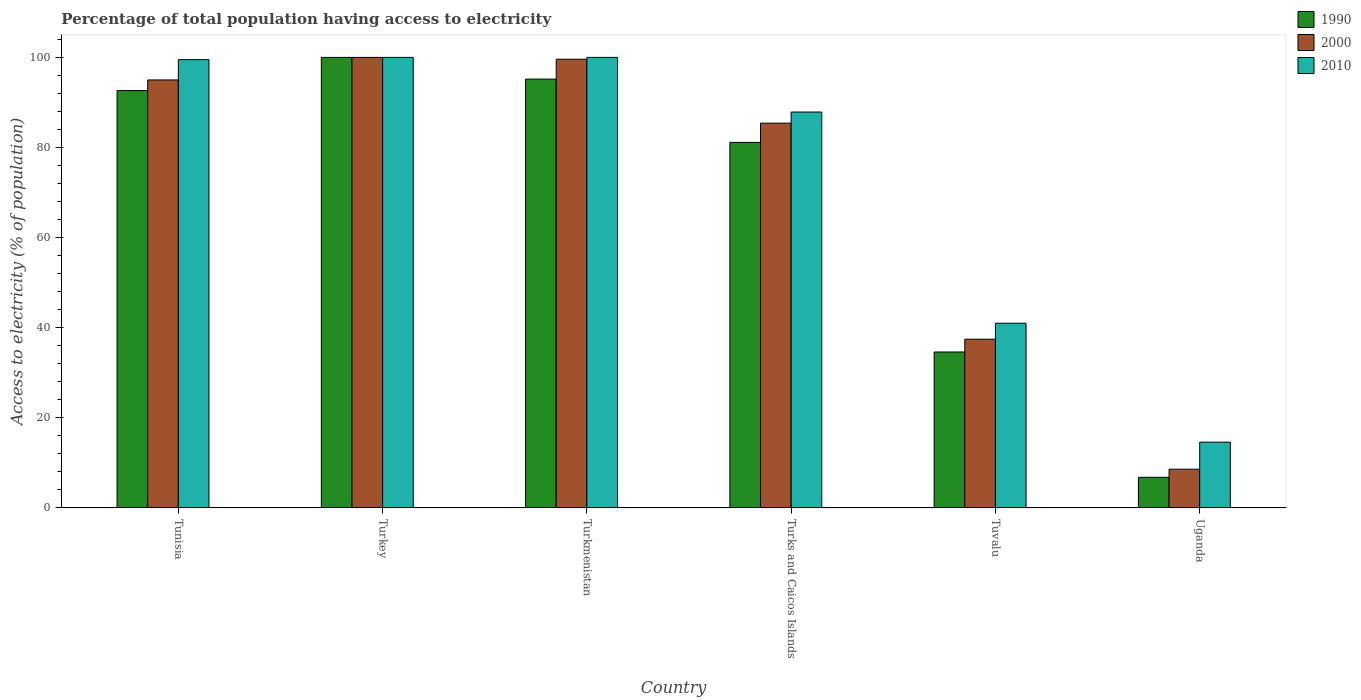How many different coloured bars are there?
Make the answer very short. 3. Are the number of bars per tick equal to the number of legend labels?
Provide a short and direct response. Yes. How many bars are there on the 2nd tick from the left?
Provide a succinct answer. 3. What is the label of the 4th group of bars from the left?
Offer a terse response. Turks and Caicos Islands. What is the percentage of population that have access to electricity in 2000 in Tunisia?
Keep it short and to the point. 95. In which country was the percentage of population that have access to electricity in 2000 minimum?
Give a very brief answer. Uganda. What is the total percentage of population that have access to electricity in 1990 in the graph?
Keep it short and to the point. 410.38. What is the difference between the percentage of population that have access to electricity in 2010 in Tunisia and that in Turkey?
Your answer should be very brief. -0.5. What is the average percentage of population that have access to electricity in 2010 per country?
Provide a succinct answer. 73.83. In how many countries, is the percentage of population that have access to electricity in 1990 greater than 48 %?
Ensure brevity in your answer.  4. What is the ratio of the percentage of population that have access to electricity in 2000 in Turkmenistan to that in Turks and Caicos Islands?
Give a very brief answer. 1.17. Is the percentage of population that have access to electricity in 2010 in Turkmenistan less than that in Uganda?
Keep it short and to the point. No. What is the difference between the highest and the second highest percentage of population that have access to electricity in 2010?
Your answer should be very brief. -0.5. What is the difference between the highest and the lowest percentage of population that have access to electricity in 2010?
Ensure brevity in your answer.  85.4. In how many countries, is the percentage of population that have access to electricity in 2010 greater than the average percentage of population that have access to electricity in 2010 taken over all countries?
Your answer should be compact. 4. Is the sum of the percentage of population that have access to electricity in 2000 in Turkey and Tuvalu greater than the maximum percentage of population that have access to electricity in 1990 across all countries?
Your answer should be compact. Yes. What does the 1st bar from the right in Turkey represents?
Offer a very short reply. 2010. Is it the case that in every country, the sum of the percentage of population that have access to electricity in 2010 and percentage of population that have access to electricity in 1990 is greater than the percentage of population that have access to electricity in 2000?
Your answer should be very brief. Yes. Are all the bars in the graph horizontal?
Your answer should be very brief. No. How many countries are there in the graph?
Your answer should be compact. 6. Does the graph contain any zero values?
Provide a succinct answer. No. Does the graph contain grids?
Offer a terse response. No. How are the legend labels stacked?
Your response must be concise. Vertical. What is the title of the graph?
Keep it short and to the point. Percentage of total population having access to electricity. Does "1999" appear as one of the legend labels in the graph?
Give a very brief answer. No. What is the label or title of the Y-axis?
Provide a short and direct response. Access to electricity (% of population). What is the Access to electricity (% of population) in 1990 in Tunisia?
Ensure brevity in your answer.  92.64. What is the Access to electricity (% of population) in 2000 in Tunisia?
Your answer should be compact. 95. What is the Access to electricity (% of population) of 2010 in Tunisia?
Give a very brief answer. 99.5. What is the Access to electricity (% of population) in 1990 in Turkey?
Your answer should be compact. 100. What is the Access to electricity (% of population) of 2010 in Turkey?
Your answer should be compact. 100. What is the Access to electricity (% of population) of 1990 in Turkmenistan?
Ensure brevity in your answer.  95.19. What is the Access to electricity (% of population) in 2000 in Turkmenistan?
Offer a very short reply. 99.6. What is the Access to electricity (% of population) of 1990 in Turks and Caicos Islands?
Offer a terse response. 81.14. What is the Access to electricity (% of population) in 2000 in Turks and Caicos Islands?
Provide a short and direct response. 85.41. What is the Access to electricity (% of population) in 2010 in Turks and Caicos Islands?
Make the answer very short. 87.87. What is the Access to electricity (% of population) of 1990 in Tuvalu?
Provide a short and direct response. 34.62. What is the Access to electricity (% of population) in 2000 in Tuvalu?
Offer a terse response. 37.46. What is the Access to electricity (% of population) in 2010 in Tuvalu?
Provide a succinct answer. 41. What is the Access to electricity (% of population) in 2010 in Uganda?
Ensure brevity in your answer.  14.6. Across all countries, what is the maximum Access to electricity (% of population) in 1990?
Offer a very short reply. 100. Across all countries, what is the maximum Access to electricity (% of population) in 2000?
Your answer should be very brief. 100. Across all countries, what is the minimum Access to electricity (% of population) in 1990?
Provide a succinct answer. 6.8. Across all countries, what is the minimum Access to electricity (% of population) of 2000?
Provide a succinct answer. 8.6. Across all countries, what is the minimum Access to electricity (% of population) of 2010?
Provide a short and direct response. 14.6. What is the total Access to electricity (% of population) of 1990 in the graph?
Provide a short and direct response. 410.38. What is the total Access to electricity (% of population) in 2000 in the graph?
Your answer should be very brief. 426.07. What is the total Access to electricity (% of population) in 2010 in the graph?
Ensure brevity in your answer.  442.97. What is the difference between the Access to electricity (% of population) in 1990 in Tunisia and that in Turkey?
Provide a succinct answer. -7.36. What is the difference between the Access to electricity (% of population) in 1990 in Tunisia and that in Turkmenistan?
Your response must be concise. -2.55. What is the difference between the Access to electricity (% of population) in 1990 in Tunisia and that in Turks and Caicos Islands?
Offer a terse response. 11.5. What is the difference between the Access to electricity (% of population) of 2000 in Tunisia and that in Turks and Caicos Islands?
Your answer should be very brief. 9.59. What is the difference between the Access to electricity (% of population) in 2010 in Tunisia and that in Turks and Caicos Islands?
Your response must be concise. 11.63. What is the difference between the Access to electricity (% of population) of 1990 in Tunisia and that in Tuvalu?
Provide a short and direct response. 58.02. What is the difference between the Access to electricity (% of population) of 2000 in Tunisia and that in Tuvalu?
Keep it short and to the point. 57.54. What is the difference between the Access to electricity (% of population) in 2010 in Tunisia and that in Tuvalu?
Provide a succinct answer. 58.5. What is the difference between the Access to electricity (% of population) of 1990 in Tunisia and that in Uganda?
Your answer should be compact. 85.84. What is the difference between the Access to electricity (% of population) of 2000 in Tunisia and that in Uganda?
Provide a succinct answer. 86.4. What is the difference between the Access to electricity (% of population) of 2010 in Tunisia and that in Uganda?
Give a very brief answer. 84.9. What is the difference between the Access to electricity (% of population) in 1990 in Turkey and that in Turkmenistan?
Your answer should be compact. 4.81. What is the difference between the Access to electricity (% of population) in 2010 in Turkey and that in Turkmenistan?
Offer a very short reply. 0. What is the difference between the Access to electricity (% of population) of 1990 in Turkey and that in Turks and Caicos Islands?
Provide a succinct answer. 18.86. What is the difference between the Access to electricity (% of population) in 2000 in Turkey and that in Turks and Caicos Islands?
Give a very brief answer. 14.59. What is the difference between the Access to electricity (% of population) of 2010 in Turkey and that in Turks and Caicos Islands?
Ensure brevity in your answer.  12.13. What is the difference between the Access to electricity (% of population) in 1990 in Turkey and that in Tuvalu?
Your response must be concise. 65.38. What is the difference between the Access to electricity (% of population) in 2000 in Turkey and that in Tuvalu?
Provide a short and direct response. 62.54. What is the difference between the Access to electricity (% of population) of 2010 in Turkey and that in Tuvalu?
Ensure brevity in your answer.  59. What is the difference between the Access to electricity (% of population) of 1990 in Turkey and that in Uganda?
Ensure brevity in your answer.  93.2. What is the difference between the Access to electricity (% of population) in 2000 in Turkey and that in Uganda?
Make the answer very short. 91.4. What is the difference between the Access to electricity (% of population) in 2010 in Turkey and that in Uganda?
Provide a short and direct response. 85.4. What is the difference between the Access to electricity (% of population) of 1990 in Turkmenistan and that in Turks and Caicos Islands?
Your response must be concise. 14.05. What is the difference between the Access to electricity (% of population) of 2000 in Turkmenistan and that in Turks and Caicos Islands?
Your answer should be very brief. 14.19. What is the difference between the Access to electricity (% of population) in 2010 in Turkmenistan and that in Turks and Caicos Islands?
Provide a short and direct response. 12.13. What is the difference between the Access to electricity (% of population) of 1990 in Turkmenistan and that in Tuvalu?
Give a very brief answer. 60.57. What is the difference between the Access to electricity (% of population) of 2000 in Turkmenistan and that in Tuvalu?
Keep it short and to the point. 62.14. What is the difference between the Access to electricity (% of population) in 1990 in Turkmenistan and that in Uganda?
Provide a succinct answer. 88.39. What is the difference between the Access to electricity (% of population) of 2000 in Turkmenistan and that in Uganda?
Your response must be concise. 91. What is the difference between the Access to electricity (% of population) in 2010 in Turkmenistan and that in Uganda?
Your answer should be very brief. 85.4. What is the difference between the Access to electricity (% of population) in 1990 in Turks and Caicos Islands and that in Tuvalu?
Provide a succinct answer. 46.52. What is the difference between the Access to electricity (% of population) of 2000 in Turks and Caicos Islands and that in Tuvalu?
Make the answer very short. 47.96. What is the difference between the Access to electricity (% of population) in 2010 in Turks and Caicos Islands and that in Tuvalu?
Offer a very short reply. 46.87. What is the difference between the Access to electricity (% of population) of 1990 in Turks and Caicos Islands and that in Uganda?
Provide a short and direct response. 74.34. What is the difference between the Access to electricity (% of population) in 2000 in Turks and Caicos Islands and that in Uganda?
Keep it short and to the point. 76.81. What is the difference between the Access to electricity (% of population) of 2010 in Turks and Caicos Islands and that in Uganda?
Provide a short and direct response. 73.27. What is the difference between the Access to electricity (% of population) in 1990 in Tuvalu and that in Uganda?
Provide a succinct answer. 27.82. What is the difference between the Access to electricity (% of population) in 2000 in Tuvalu and that in Uganda?
Ensure brevity in your answer.  28.86. What is the difference between the Access to electricity (% of population) of 2010 in Tuvalu and that in Uganda?
Offer a terse response. 26.4. What is the difference between the Access to electricity (% of population) of 1990 in Tunisia and the Access to electricity (% of population) of 2000 in Turkey?
Offer a terse response. -7.36. What is the difference between the Access to electricity (% of population) of 1990 in Tunisia and the Access to electricity (% of population) of 2010 in Turkey?
Offer a very short reply. -7.36. What is the difference between the Access to electricity (% of population) in 2000 in Tunisia and the Access to electricity (% of population) in 2010 in Turkey?
Your response must be concise. -5. What is the difference between the Access to electricity (% of population) of 1990 in Tunisia and the Access to electricity (% of population) of 2000 in Turkmenistan?
Your response must be concise. -6.96. What is the difference between the Access to electricity (% of population) in 1990 in Tunisia and the Access to electricity (% of population) in 2010 in Turkmenistan?
Provide a short and direct response. -7.36. What is the difference between the Access to electricity (% of population) in 2000 in Tunisia and the Access to electricity (% of population) in 2010 in Turkmenistan?
Your response must be concise. -5. What is the difference between the Access to electricity (% of population) of 1990 in Tunisia and the Access to electricity (% of population) of 2000 in Turks and Caicos Islands?
Your answer should be compact. 7.23. What is the difference between the Access to electricity (% of population) of 1990 in Tunisia and the Access to electricity (% of population) of 2010 in Turks and Caicos Islands?
Your answer should be very brief. 4.76. What is the difference between the Access to electricity (% of population) of 2000 in Tunisia and the Access to electricity (% of population) of 2010 in Turks and Caicos Islands?
Offer a terse response. 7.13. What is the difference between the Access to electricity (% of population) in 1990 in Tunisia and the Access to electricity (% of population) in 2000 in Tuvalu?
Your answer should be very brief. 55.18. What is the difference between the Access to electricity (% of population) in 1990 in Tunisia and the Access to electricity (% of population) in 2010 in Tuvalu?
Offer a terse response. 51.64. What is the difference between the Access to electricity (% of population) of 2000 in Tunisia and the Access to electricity (% of population) of 2010 in Tuvalu?
Make the answer very short. 54. What is the difference between the Access to electricity (% of population) of 1990 in Tunisia and the Access to electricity (% of population) of 2000 in Uganda?
Offer a very short reply. 84.04. What is the difference between the Access to electricity (% of population) of 1990 in Tunisia and the Access to electricity (% of population) of 2010 in Uganda?
Give a very brief answer. 78.04. What is the difference between the Access to electricity (% of population) in 2000 in Tunisia and the Access to electricity (% of population) in 2010 in Uganda?
Provide a succinct answer. 80.4. What is the difference between the Access to electricity (% of population) of 1990 in Turkey and the Access to electricity (% of population) of 2010 in Turkmenistan?
Provide a succinct answer. 0. What is the difference between the Access to electricity (% of population) in 1990 in Turkey and the Access to electricity (% of population) in 2000 in Turks and Caicos Islands?
Make the answer very short. 14.59. What is the difference between the Access to electricity (% of population) in 1990 in Turkey and the Access to electricity (% of population) in 2010 in Turks and Caicos Islands?
Your response must be concise. 12.13. What is the difference between the Access to electricity (% of population) of 2000 in Turkey and the Access to electricity (% of population) of 2010 in Turks and Caicos Islands?
Give a very brief answer. 12.13. What is the difference between the Access to electricity (% of population) of 1990 in Turkey and the Access to electricity (% of population) of 2000 in Tuvalu?
Offer a very short reply. 62.54. What is the difference between the Access to electricity (% of population) in 2000 in Turkey and the Access to electricity (% of population) in 2010 in Tuvalu?
Give a very brief answer. 59. What is the difference between the Access to electricity (% of population) in 1990 in Turkey and the Access to electricity (% of population) in 2000 in Uganda?
Make the answer very short. 91.4. What is the difference between the Access to electricity (% of population) of 1990 in Turkey and the Access to electricity (% of population) of 2010 in Uganda?
Provide a succinct answer. 85.4. What is the difference between the Access to electricity (% of population) of 2000 in Turkey and the Access to electricity (% of population) of 2010 in Uganda?
Make the answer very short. 85.4. What is the difference between the Access to electricity (% of population) of 1990 in Turkmenistan and the Access to electricity (% of population) of 2000 in Turks and Caicos Islands?
Offer a terse response. 9.78. What is the difference between the Access to electricity (% of population) of 1990 in Turkmenistan and the Access to electricity (% of population) of 2010 in Turks and Caicos Islands?
Make the answer very short. 7.31. What is the difference between the Access to electricity (% of population) of 2000 in Turkmenistan and the Access to electricity (% of population) of 2010 in Turks and Caicos Islands?
Give a very brief answer. 11.73. What is the difference between the Access to electricity (% of population) in 1990 in Turkmenistan and the Access to electricity (% of population) in 2000 in Tuvalu?
Keep it short and to the point. 57.73. What is the difference between the Access to electricity (% of population) in 1990 in Turkmenistan and the Access to electricity (% of population) in 2010 in Tuvalu?
Your response must be concise. 54.19. What is the difference between the Access to electricity (% of population) in 2000 in Turkmenistan and the Access to electricity (% of population) in 2010 in Tuvalu?
Your response must be concise. 58.6. What is the difference between the Access to electricity (% of population) in 1990 in Turkmenistan and the Access to electricity (% of population) in 2000 in Uganda?
Make the answer very short. 86.59. What is the difference between the Access to electricity (% of population) of 1990 in Turkmenistan and the Access to electricity (% of population) of 2010 in Uganda?
Your response must be concise. 80.59. What is the difference between the Access to electricity (% of population) in 1990 in Turks and Caicos Islands and the Access to electricity (% of population) in 2000 in Tuvalu?
Make the answer very short. 43.68. What is the difference between the Access to electricity (% of population) in 1990 in Turks and Caicos Islands and the Access to electricity (% of population) in 2010 in Tuvalu?
Your response must be concise. 40.14. What is the difference between the Access to electricity (% of population) in 2000 in Turks and Caicos Islands and the Access to electricity (% of population) in 2010 in Tuvalu?
Your answer should be compact. 44.41. What is the difference between the Access to electricity (% of population) of 1990 in Turks and Caicos Islands and the Access to electricity (% of population) of 2000 in Uganda?
Your answer should be compact. 72.54. What is the difference between the Access to electricity (% of population) in 1990 in Turks and Caicos Islands and the Access to electricity (% of population) in 2010 in Uganda?
Your response must be concise. 66.54. What is the difference between the Access to electricity (% of population) of 2000 in Turks and Caicos Islands and the Access to electricity (% of population) of 2010 in Uganda?
Your response must be concise. 70.81. What is the difference between the Access to electricity (% of population) of 1990 in Tuvalu and the Access to electricity (% of population) of 2000 in Uganda?
Your answer should be compact. 26.02. What is the difference between the Access to electricity (% of population) in 1990 in Tuvalu and the Access to electricity (% of population) in 2010 in Uganda?
Provide a succinct answer. 20.02. What is the difference between the Access to electricity (% of population) in 2000 in Tuvalu and the Access to electricity (% of population) in 2010 in Uganda?
Provide a succinct answer. 22.86. What is the average Access to electricity (% of population) of 1990 per country?
Offer a very short reply. 68.4. What is the average Access to electricity (% of population) in 2000 per country?
Your answer should be compact. 71.01. What is the average Access to electricity (% of population) in 2010 per country?
Your answer should be compact. 73.83. What is the difference between the Access to electricity (% of population) of 1990 and Access to electricity (% of population) of 2000 in Tunisia?
Your response must be concise. -2.36. What is the difference between the Access to electricity (% of population) in 1990 and Access to electricity (% of population) in 2010 in Tunisia?
Provide a succinct answer. -6.86. What is the difference between the Access to electricity (% of population) in 2000 and Access to electricity (% of population) in 2010 in Tunisia?
Ensure brevity in your answer.  -4.5. What is the difference between the Access to electricity (% of population) in 1990 and Access to electricity (% of population) in 2000 in Turkmenistan?
Ensure brevity in your answer.  -4.41. What is the difference between the Access to electricity (% of population) in 1990 and Access to electricity (% of population) in 2010 in Turkmenistan?
Offer a very short reply. -4.81. What is the difference between the Access to electricity (% of population) of 2000 and Access to electricity (% of population) of 2010 in Turkmenistan?
Keep it short and to the point. -0.4. What is the difference between the Access to electricity (% of population) of 1990 and Access to electricity (% of population) of 2000 in Turks and Caicos Islands?
Your response must be concise. -4.28. What is the difference between the Access to electricity (% of population) of 1990 and Access to electricity (% of population) of 2010 in Turks and Caicos Islands?
Your answer should be very brief. -6.74. What is the difference between the Access to electricity (% of population) of 2000 and Access to electricity (% of population) of 2010 in Turks and Caicos Islands?
Keep it short and to the point. -2.46. What is the difference between the Access to electricity (% of population) in 1990 and Access to electricity (% of population) in 2000 in Tuvalu?
Provide a succinct answer. -2.84. What is the difference between the Access to electricity (% of population) of 1990 and Access to electricity (% of population) of 2010 in Tuvalu?
Your answer should be compact. -6.38. What is the difference between the Access to electricity (% of population) of 2000 and Access to electricity (% of population) of 2010 in Tuvalu?
Provide a short and direct response. -3.54. What is the difference between the Access to electricity (% of population) of 2000 and Access to electricity (% of population) of 2010 in Uganda?
Ensure brevity in your answer.  -6. What is the ratio of the Access to electricity (% of population) of 1990 in Tunisia to that in Turkey?
Give a very brief answer. 0.93. What is the ratio of the Access to electricity (% of population) in 2000 in Tunisia to that in Turkey?
Offer a terse response. 0.95. What is the ratio of the Access to electricity (% of population) of 2010 in Tunisia to that in Turkey?
Provide a succinct answer. 0.99. What is the ratio of the Access to electricity (% of population) of 1990 in Tunisia to that in Turkmenistan?
Ensure brevity in your answer.  0.97. What is the ratio of the Access to electricity (% of population) in 2000 in Tunisia to that in Turkmenistan?
Give a very brief answer. 0.95. What is the ratio of the Access to electricity (% of population) in 1990 in Tunisia to that in Turks and Caicos Islands?
Ensure brevity in your answer.  1.14. What is the ratio of the Access to electricity (% of population) of 2000 in Tunisia to that in Turks and Caicos Islands?
Ensure brevity in your answer.  1.11. What is the ratio of the Access to electricity (% of population) in 2010 in Tunisia to that in Turks and Caicos Islands?
Ensure brevity in your answer.  1.13. What is the ratio of the Access to electricity (% of population) of 1990 in Tunisia to that in Tuvalu?
Your answer should be compact. 2.68. What is the ratio of the Access to electricity (% of population) of 2000 in Tunisia to that in Tuvalu?
Provide a succinct answer. 2.54. What is the ratio of the Access to electricity (% of population) in 2010 in Tunisia to that in Tuvalu?
Provide a succinct answer. 2.43. What is the ratio of the Access to electricity (% of population) in 1990 in Tunisia to that in Uganda?
Give a very brief answer. 13.62. What is the ratio of the Access to electricity (% of population) of 2000 in Tunisia to that in Uganda?
Provide a short and direct response. 11.05. What is the ratio of the Access to electricity (% of population) of 2010 in Tunisia to that in Uganda?
Offer a terse response. 6.82. What is the ratio of the Access to electricity (% of population) in 1990 in Turkey to that in Turkmenistan?
Make the answer very short. 1.05. What is the ratio of the Access to electricity (% of population) in 2010 in Turkey to that in Turkmenistan?
Give a very brief answer. 1. What is the ratio of the Access to electricity (% of population) in 1990 in Turkey to that in Turks and Caicos Islands?
Give a very brief answer. 1.23. What is the ratio of the Access to electricity (% of population) of 2000 in Turkey to that in Turks and Caicos Islands?
Make the answer very short. 1.17. What is the ratio of the Access to electricity (% of population) in 2010 in Turkey to that in Turks and Caicos Islands?
Offer a very short reply. 1.14. What is the ratio of the Access to electricity (% of population) of 1990 in Turkey to that in Tuvalu?
Keep it short and to the point. 2.89. What is the ratio of the Access to electricity (% of population) of 2000 in Turkey to that in Tuvalu?
Your answer should be very brief. 2.67. What is the ratio of the Access to electricity (% of population) in 2010 in Turkey to that in Tuvalu?
Your answer should be compact. 2.44. What is the ratio of the Access to electricity (% of population) in 1990 in Turkey to that in Uganda?
Make the answer very short. 14.71. What is the ratio of the Access to electricity (% of population) of 2000 in Turkey to that in Uganda?
Provide a succinct answer. 11.63. What is the ratio of the Access to electricity (% of population) in 2010 in Turkey to that in Uganda?
Provide a short and direct response. 6.85. What is the ratio of the Access to electricity (% of population) in 1990 in Turkmenistan to that in Turks and Caicos Islands?
Offer a terse response. 1.17. What is the ratio of the Access to electricity (% of population) of 2000 in Turkmenistan to that in Turks and Caicos Islands?
Your answer should be compact. 1.17. What is the ratio of the Access to electricity (% of population) in 2010 in Turkmenistan to that in Turks and Caicos Islands?
Provide a short and direct response. 1.14. What is the ratio of the Access to electricity (% of population) of 1990 in Turkmenistan to that in Tuvalu?
Give a very brief answer. 2.75. What is the ratio of the Access to electricity (% of population) of 2000 in Turkmenistan to that in Tuvalu?
Provide a short and direct response. 2.66. What is the ratio of the Access to electricity (% of population) in 2010 in Turkmenistan to that in Tuvalu?
Give a very brief answer. 2.44. What is the ratio of the Access to electricity (% of population) of 1990 in Turkmenistan to that in Uganda?
Your response must be concise. 14. What is the ratio of the Access to electricity (% of population) in 2000 in Turkmenistan to that in Uganda?
Provide a short and direct response. 11.58. What is the ratio of the Access to electricity (% of population) of 2010 in Turkmenistan to that in Uganda?
Provide a succinct answer. 6.85. What is the ratio of the Access to electricity (% of population) in 1990 in Turks and Caicos Islands to that in Tuvalu?
Offer a terse response. 2.34. What is the ratio of the Access to electricity (% of population) in 2000 in Turks and Caicos Islands to that in Tuvalu?
Your response must be concise. 2.28. What is the ratio of the Access to electricity (% of population) of 2010 in Turks and Caicos Islands to that in Tuvalu?
Give a very brief answer. 2.14. What is the ratio of the Access to electricity (% of population) in 1990 in Turks and Caicos Islands to that in Uganda?
Provide a short and direct response. 11.93. What is the ratio of the Access to electricity (% of population) in 2000 in Turks and Caicos Islands to that in Uganda?
Make the answer very short. 9.93. What is the ratio of the Access to electricity (% of population) of 2010 in Turks and Caicos Islands to that in Uganda?
Offer a very short reply. 6.02. What is the ratio of the Access to electricity (% of population) of 1990 in Tuvalu to that in Uganda?
Offer a very short reply. 5.09. What is the ratio of the Access to electricity (% of population) in 2000 in Tuvalu to that in Uganda?
Provide a succinct answer. 4.36. What is the ratio of the Access to electricity (% of population) of 2010 in Tuvalu to that in Uganda?
Offer a terse response. 2.81. What is the difference between the highest and the second highest Access to electricity (% of population) of 1990?
Your response must be concise. 4.81. What is the difference between the highest and the second highest Access to electricity (% of population) in 2000?
Your answer should be very brief. 0.4. What is the difference between the highest and the lowest Access to electricity (% of population) of 1990?
Give a very brief answer. 93.2. What is the difference between the highest and the lowest Access to electricity (% of population) in 2000?
Your answer should be compact. 91.4. What is the difference between the highest and the lowest Access to electricity (% of population) of 2010?
Give a very brief answer. 85.4. 